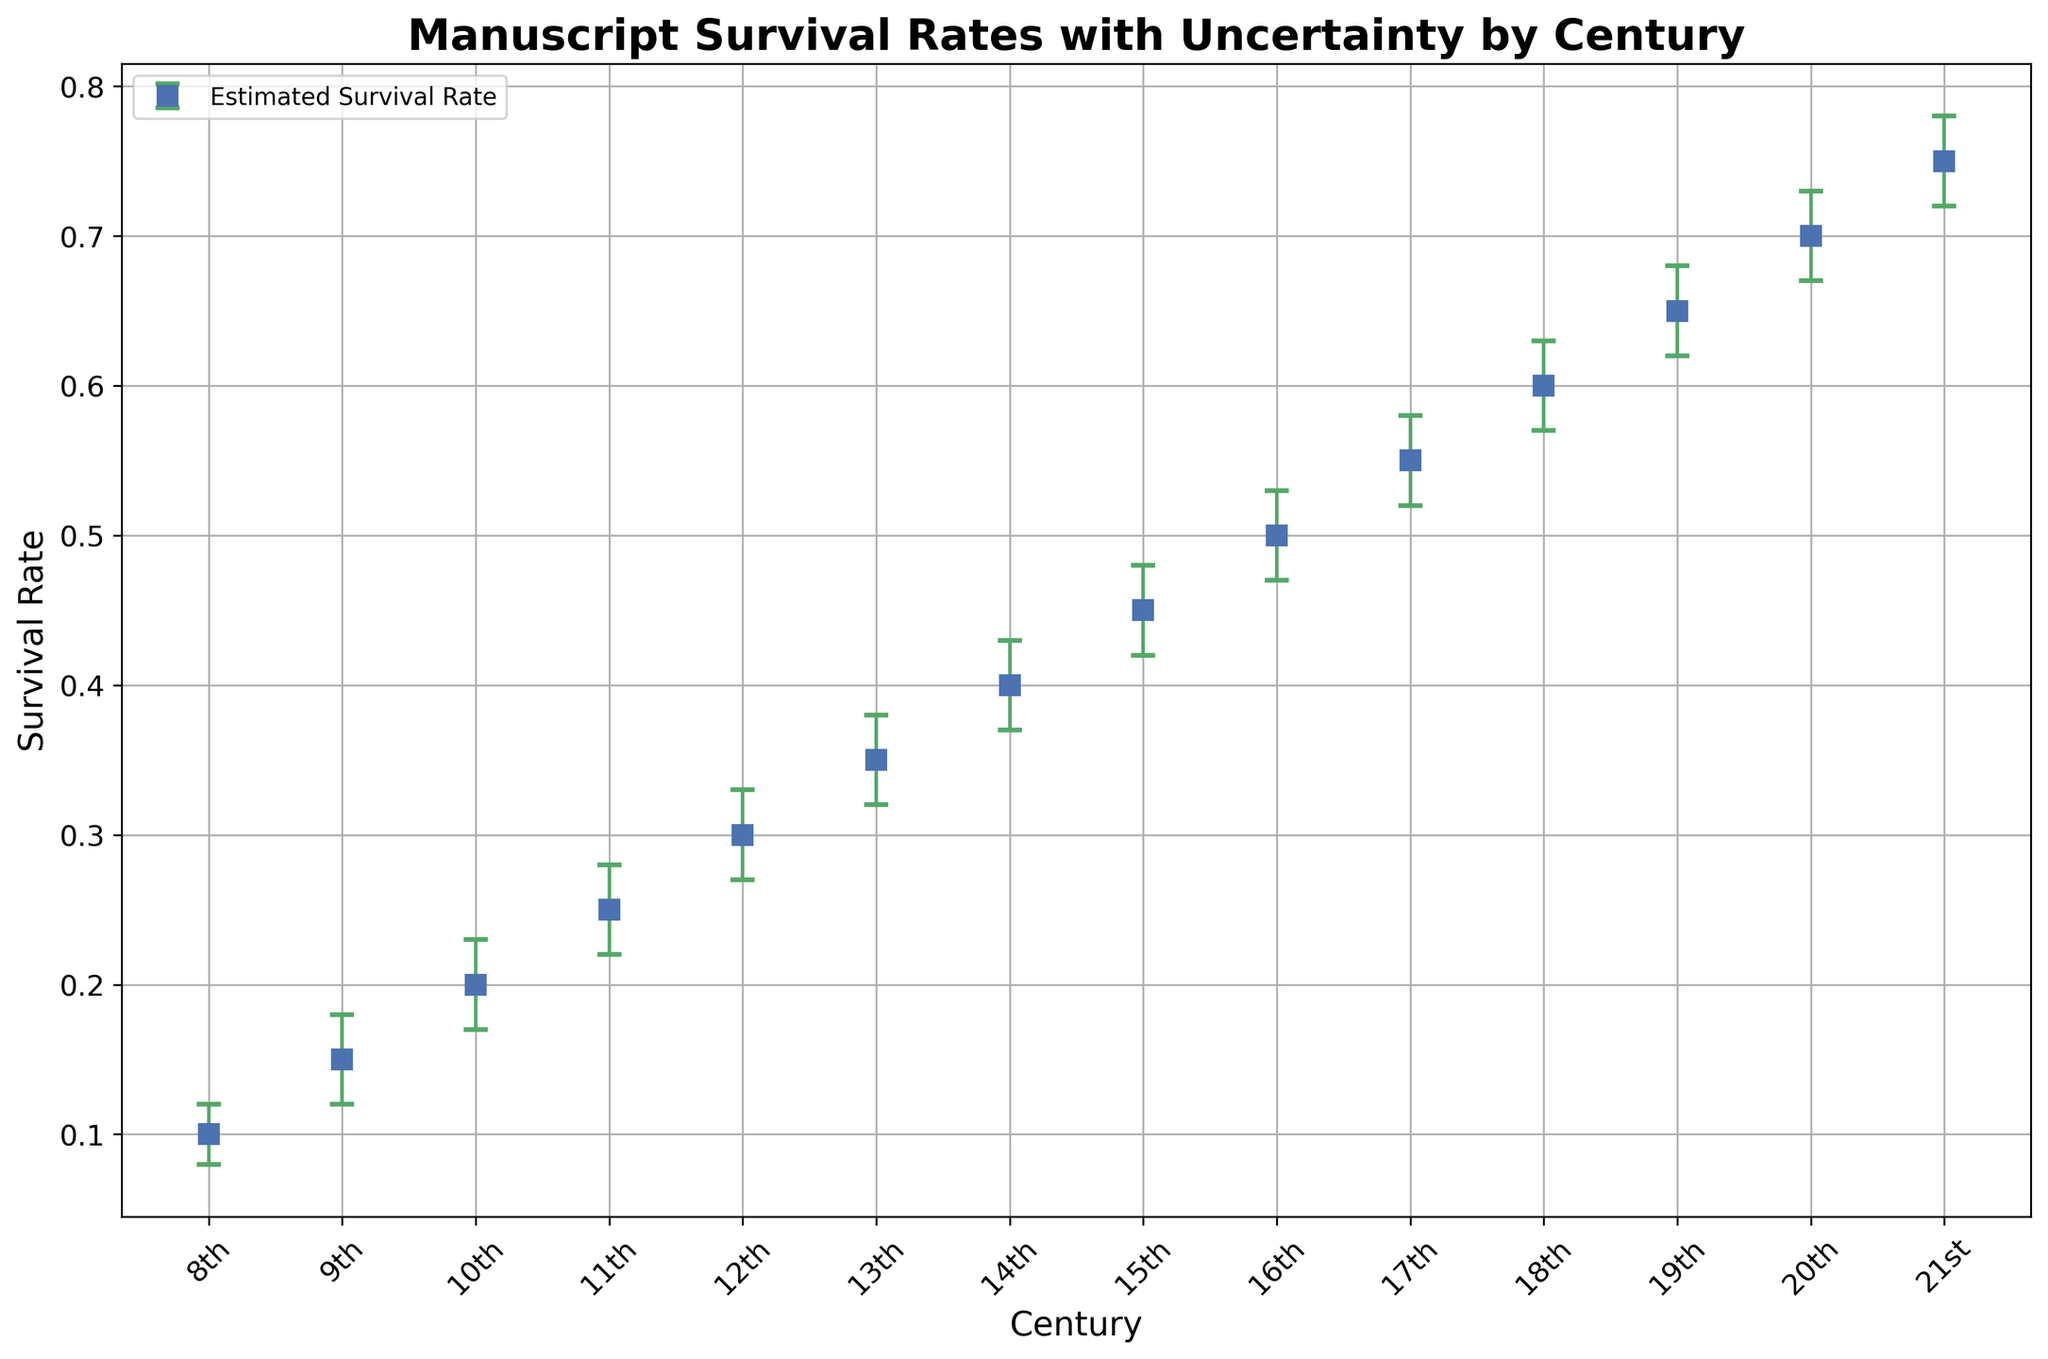What is the estimated manuscript survival rate for the 10th century? The estimated survival rate for each century is represented by the blue markers in the figure. The marker for the 10th century shows an estimated survival rate of 0.2.
Answer: 0.2 Which century has the highest estimated manuscript survival rate? By looking at the blue markers for different centuries, the 21st century shows the highest estimated survival rate of 0.75.
Answer: 21st What is the range covered by the error bars for the 15th century? The error bars for the 15th century range from the lower 95% confidence interval to the upper 95% confidence interval. For the 15th century, this range is from 0.42 to 0.48.
Answer: 0.06 Compare the survival rates between the 9th and 10th centuries. Which has a higher rate and by how much? The 9th century has an estimated survival rate of 0.15, whereas the 10th century has an estimated survival rate of 0.2. The difference is 0.2 - 0.15 = 0.05.
Answer: 10th, by 0.05 What is the average estimated survival rate for the centuries from the 18th to the 21st? The estimated survival rates for the 18th, 19th, 20th, and 21st centuries are 0.60, 0.65, 0.70, and 0.75, respectively. The average is calculated as (0.60 + 0.65 + 0.70 + 0.75) / 4 = 2.70 / 4 = 0.675.
Answer: 0.675 What is the relative increase in the estimated survival rate from the 8th to the 21st century? The estimated survival rate increases from 0.1 in the 8th century to 0.75 in the 21st century. The relative increase is (0.75 - 0.1) / 0.1 = 0.65 / 0.1 = 6.5 or 650%.
Answer: 650% How does the uncertainty in survival rates (width of the error bars) change from the 8th to the 21st century? The uncertainty is represented by the length of the error bars. For the 8th century, the uncertainty range is 0.12 - 0.08 = 0.04. For the 21st century, the uncertainty range is 0.78 - 0.72 = 0.06. The uncertainty increases from the 8th to the 21st century.
Answer: Increases During which century is the estimated survival rate first at or above 0.5? By examining the blue markers in the figure, the estimated survival rate first reaches 0.5 in the 16th century.
Answer: 16th What are the estimated survival rates and their uncertainties for the 11th and 12th centuries? Compare them. For the 11th century, the estimated survival rate is 0.25 with an uncertainty range of 0.22 to 0.28. For the 12th century, the estimated survival rate is 0.30 with an uncertainty range of 0.27 to 0.33.
Answer: 11th: 0.25 (0.22-0.28), 12th: 0.30 (0.27-0.33) Which century shows the smallest uncertainty in the survival rate and what is the value? To determine the smallest uncertainty, we compare the widths of the error bars. The 8th century has the smallest uncertainty range of 0.04 (from 0.12 - 0.08).
Answer: 8th, 0.04 